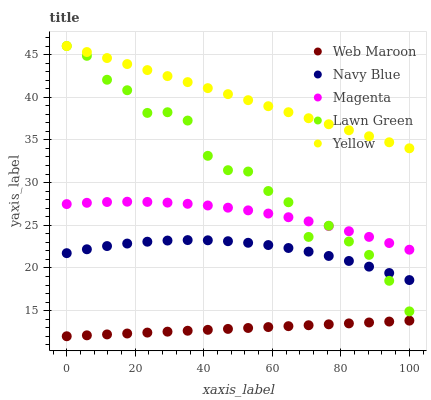Does Web Maroon have the minimum area under the curve?
Answer yes or no. Yes. Does Yellow have the maximum area under the curve?
Answer yes or no. Yes. Does Magenta have the minimum area under the curve?
Answer yes or no. No. Does Magenta have the maximum area under the curve?
Answer yes or no. No. Is Web Maroon the smoothest?
Answer yes or no. Yes. Is Lawn Green the roughest?
Answer yes or no. Yes. Is Magenta the smoothest?
Answer yes or no. No. Is Magenta the roughest?
Answer yes or no. No. Does Web Maroon have the lowest value?
Answer yes or no. Yes. Does Magenta have the lowest value?
Answer yes or no. No. Does Lawn Green have the highest value?
Answer yes or no. Yes. Does Magenta have the highest value?
Answer yes or no. No. Is Magenta less than Yellow?
Answer yes or no. Yes. Is Magenta greater than Web Maroon?
Answer yes or no. Yes. Does Lawn Green intersect Magenta?
Answer yes or no. Yes. Is Lawn Green less than Magenta?
Answer yes or no. No. Is Lawn Green greater than Magenta?
Answer yes or no. No. Does Magenta intersect Yellow?
Answer yes or no. No. 